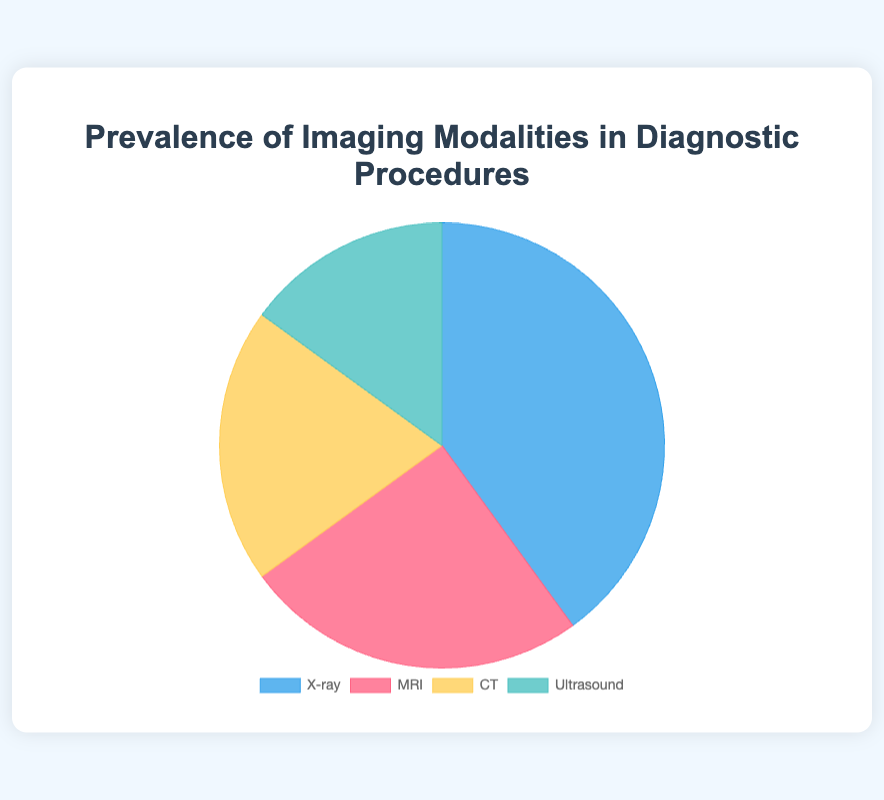Which imaging modality is the most prevalent? To find the most prevalent imaging modality, look for the largest slice in the pie chart, which is labeled "X-ray" with a percentage of 40%.
Answer: X-ray Which imaging modality is the least prevalent? The least prevalent imaging modality is represented by the smallest slice in the pie chart, labeled "Ultrasound" with a percentage of 15%.
Answer: Ultrasound What is the combined prevalence of CT and Ultrasound? Add the percentages of CT (20%) and Ultrasound (15%) together to get the combined prevalence. 20% + 15% = 35%.
Answer: 35% By how much does the prevalence of X-ray exceed that of MRI? Subtract the percentage of MRI (25%) from the percentage of X-ray (40%). 40% - 25% = 15%.
Answer: 15% Which two modalities together make up half of the total prevalence? Identify two modalities whose combined percentage equals 50%. X-ray (40%) and Ultrasound (15%) together equal 55%, X-ray (40%) and CT (20%) together equal 60%, MRI (25%) and CT (20%) together equal 45%. MRI (25%) and Ultrasound (15%) together equal 40%. Thus, none of the combinations make up exactly 50%. The closest pair is MRI and CT with 45%.
Answer: MRI and CT What is the difference in prevalence between the most and least prevalent modalities? Subtract the percentage of the least prevalent modality (Ultrasound, 15%) from the most prevalent modality (X-ray, 40%). 40% - 15% = 25%.
Answer: 25% Which modalities together account for more than 60% of the total prevalence? Add the percentages of different combinations: X-ray (40%), MRI (25%) equals 65%; X-ray (40%) and CT (20%) equals 60%. So, X-ray and MRI together account for more than 60%.
Answer: X-ray and MRI What is the average prevalence of all four imaging modalities? Add the percentages of all four modalities: X-ray (40%), MRI (25%), CT (20%), Ultrasound (15%). Then divide by the number of modalities (4). (40% + 25% + 20% + 15%) / 4 = 25%.
Answer: 25% What is the median prevalence value of the four imaging modalities? Organize the percentages in ascending order: 15% (Ultrasound), 20% (CT), 25% (MRI), 40% (X-ray). The median is the average of the two middle numbers: (20% + 25%) / 2 = 22.5%.
Answer: 22.5% 